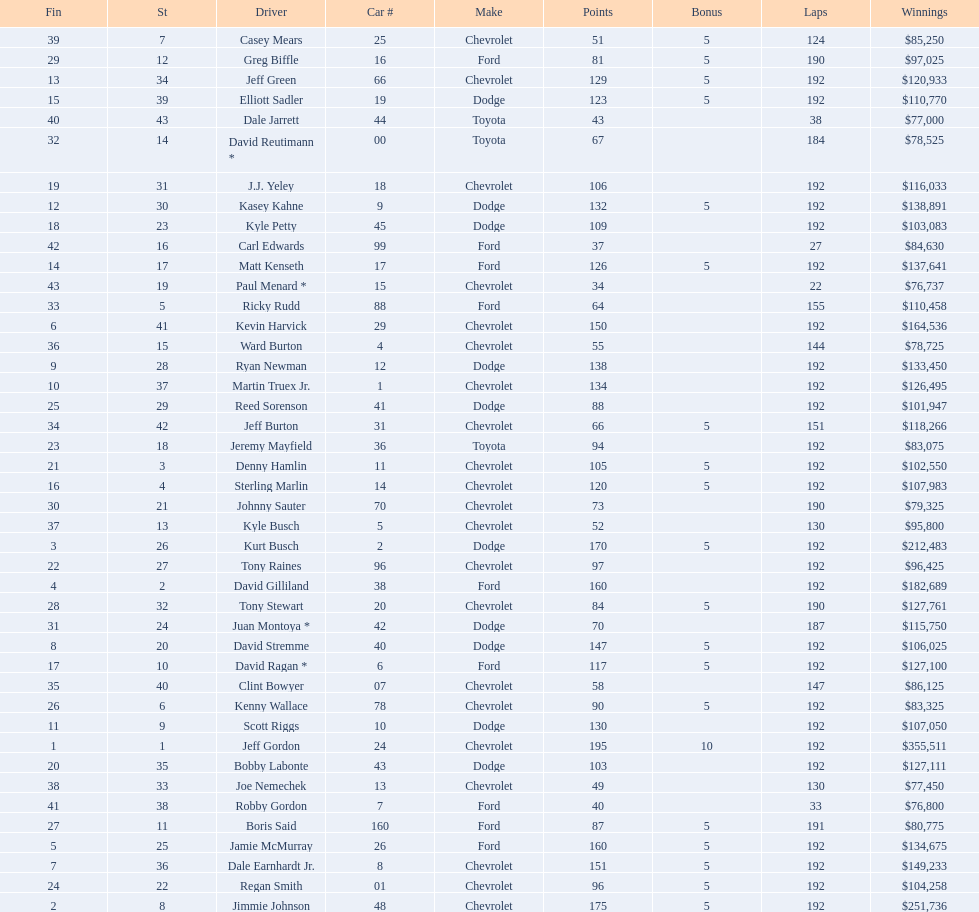What make did kurt busch drive? Dodge. 